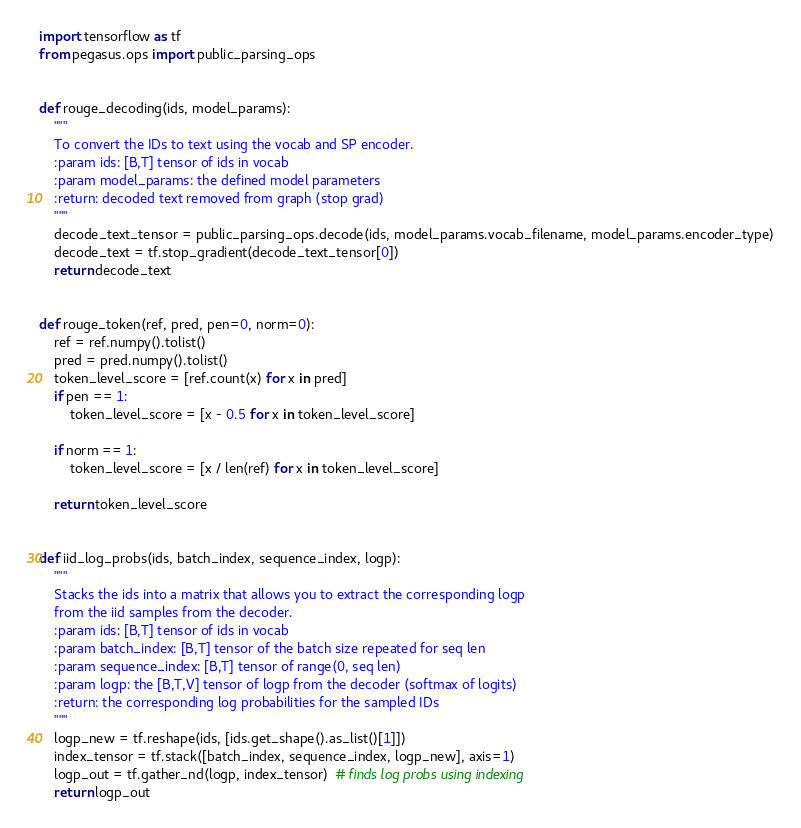Convert code to text. <code><loc_0><loc_0><loc_500><loc_500><_Python_>import tensorflow as tf
from pegasus.ops import public_parsing_ops


def rouge_decoding(ids, model_params):
    """
    To convert the IDs to text using the vocab and SP encoder.
    :param ids: [B,T] tensor of ids in vocab
    :param model_params: the defined model parameters
    :return: decoded text removed from graph (stop grad)
    """
    decode_text_tensor = public_parsing_ops.decode(ids, model_params.vocab_filename, model_params.encoder_type)
    decode_text = tf.stop_gradient(decode_text_tensor[0])
    return decode_text


def rouge_token(ref, pred, pen=0, norm=0):
    ref = ref.numpy().tolist()
    pred = pred.numpy().tolist()
    token_level_score = [ref.count(x) for x in pred]
    if pen == 1:
        token_level_score = [x - 0.5 for x in token_level_score]

    if norm == 1:
        token_level_score = [x / len(ref) for x in token_level_score]

    return token_level_score


def iid_log_probs(ids, batch_index, sequence_index, logp):
    """
    Stacks the ids into a matrix that allows you to extract the corresponding logp
    from the iid samples from the decoder.
    :param ids: [B,T] tensor of ids in vocab
    :param batch_index: [B,T] tensor of the batch size repeated for seq len
    :param sequence_index: [B,T] tensor of range(0, seq len)
    :param logp: the [B,T,V] tensor of logp from the decoder (softmax of logits)
    :return: the corresponding log probabilities for the sampled IDs
    """
    logp_new = tf.reshape(ids, [ids.get_shape().as_list()[1]])
    index_tensor = tf.stack([batch_index, sequence_index, logp_new], axis=1)
    logp_out = tf.gather_nd(logp, index_tensor)  # finds log probs using indexing
    return logp_out
</code> 